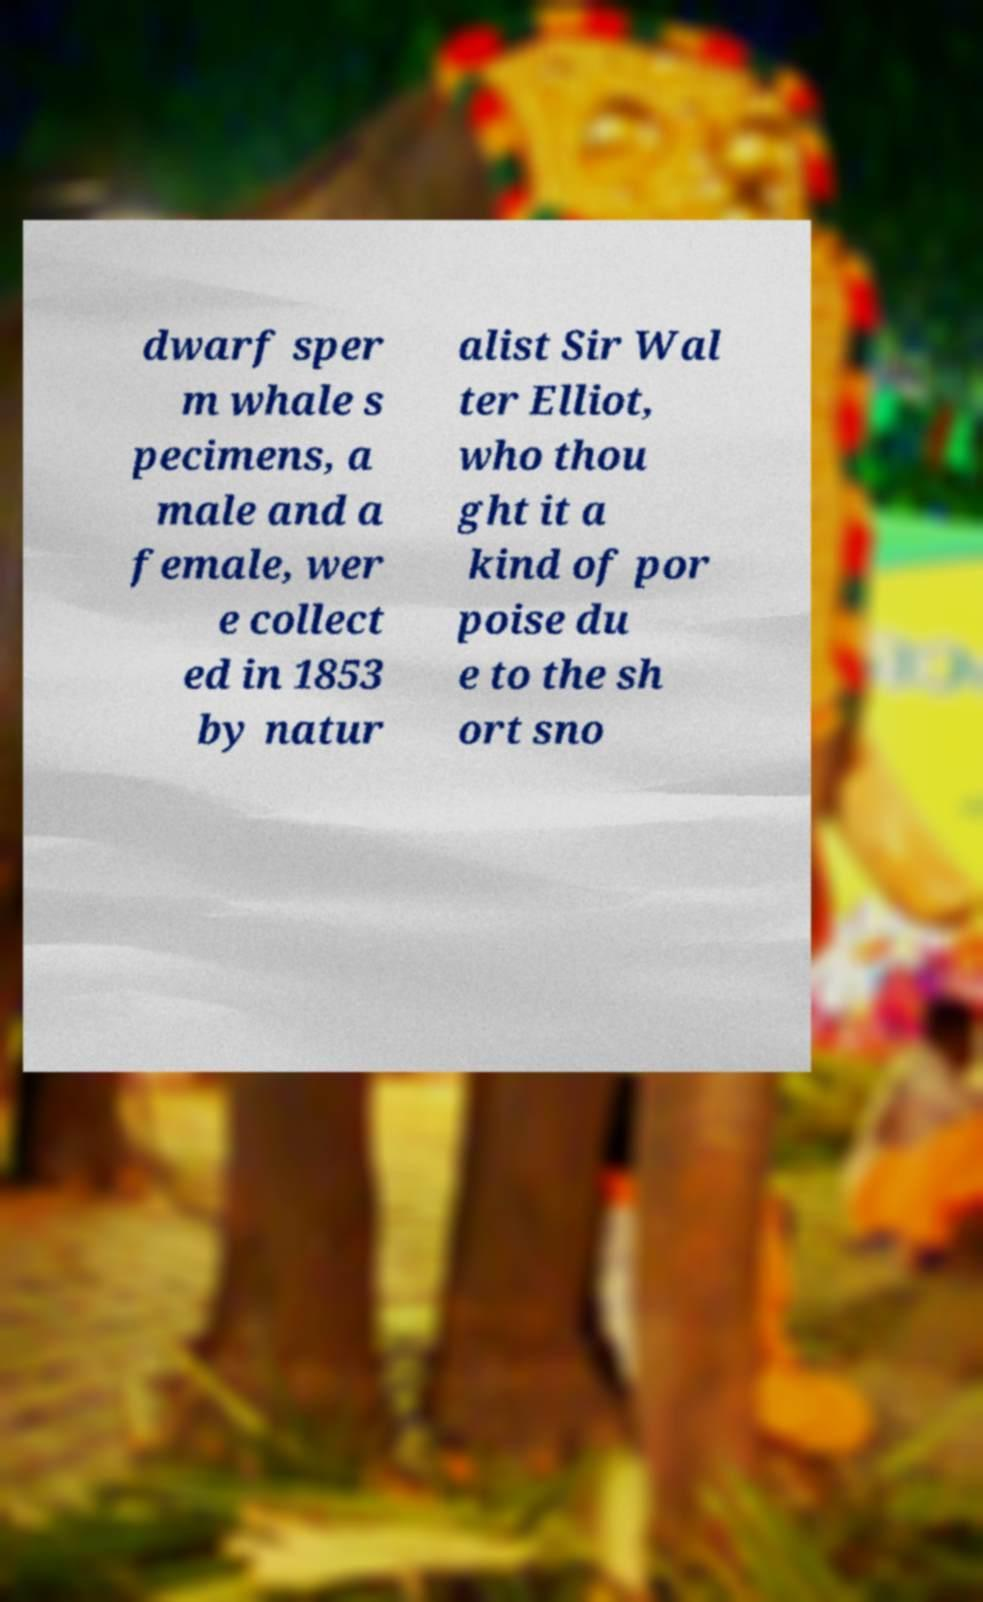Could you assist in decoding the text presented in this image and type it out clearly? dwarf sper m whale s pecimens, a male and a female, wer e collect ed in 1853 by natur alist Sir Wal ter Elliot, who thou ght it a kind of por poise du e to the sh ort sno 